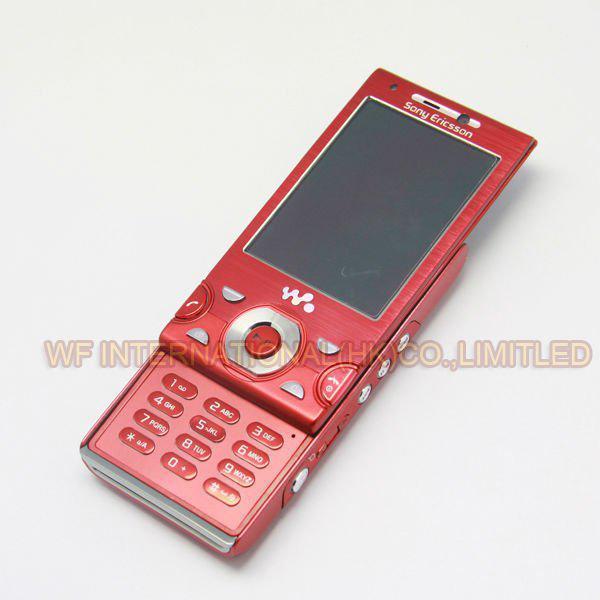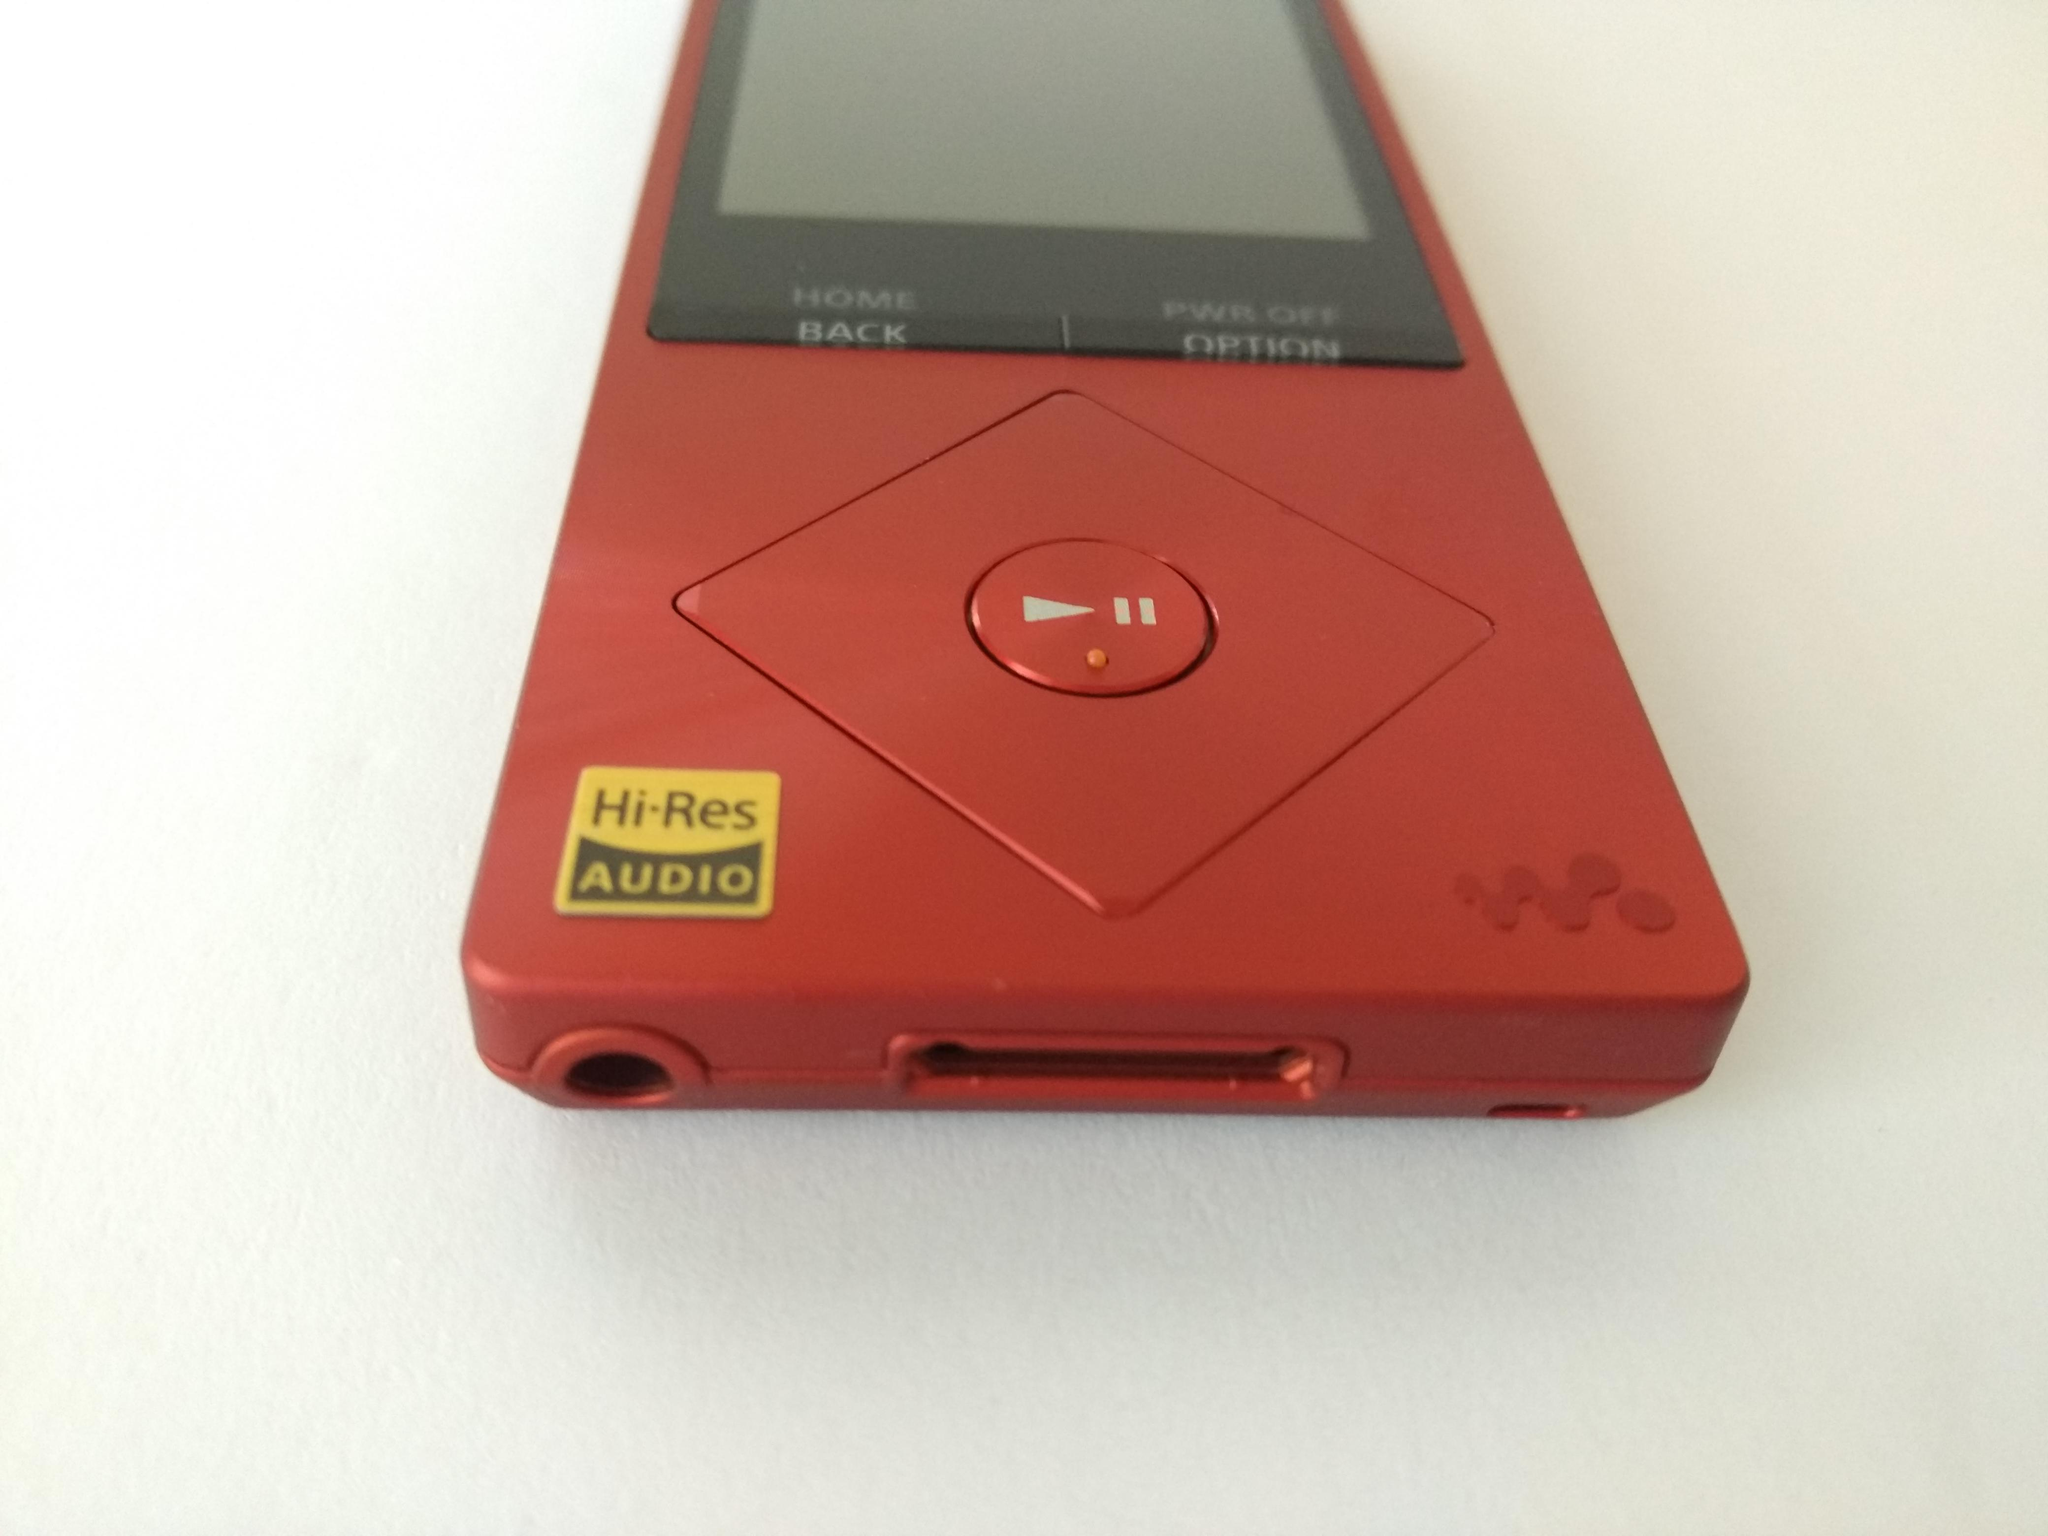The first image is the image on the left, the second image is the image on the right. Considering the images on both sides, is "One image shows the back of the phone." valid? Answer yes or no. No. The first image is the image on the left, the second image is the image on the right. Examine the images to the left and right. Is the description "Each image contains one red device, and at least one of the devices pictured has a round button inside a red diamond shape at the bottom." accurate? Answer yes or no. Yes. 